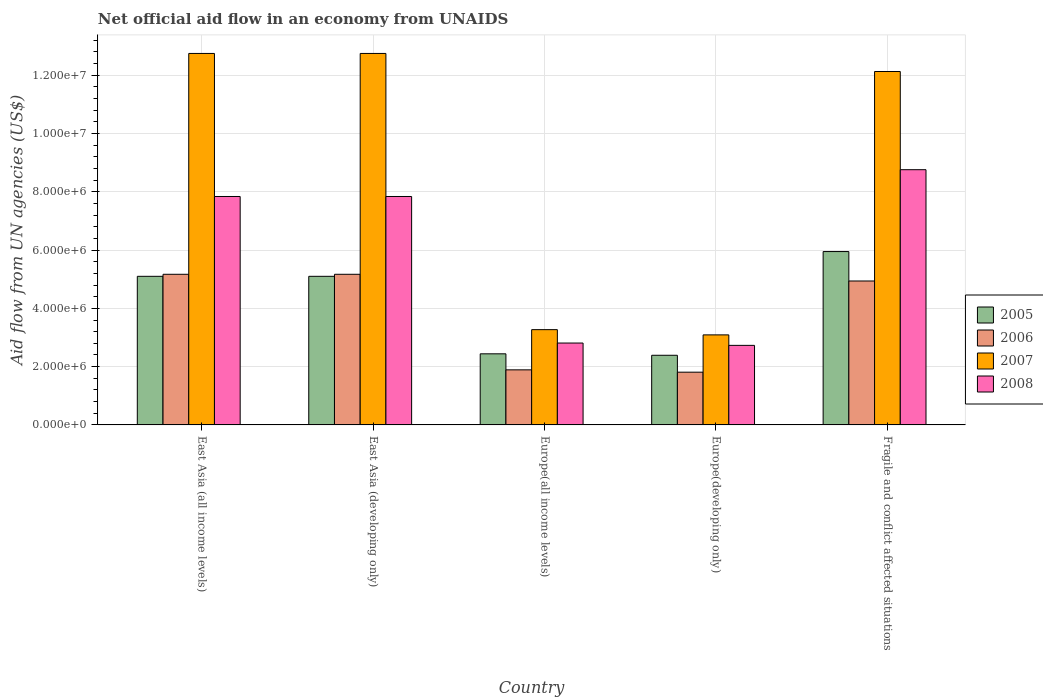How many different coloured bars are there?
Keep it short and to the point. 4. Are the number of bars per tick equal to the number of legend labels?
Give a very brief answer. Yes. How many bars are there on the 4th tick from the left?
Your answer should be compact. 4. How many bars are there on the 4th tick from the right?
Your response must be concise. 4. What is the label of the 3rd group of bars from the left?
Your response must be concise. Europe(all income levels). What is the net official aid flow in 2005 in Europe(all income levels)?
Provide a short and direct response. 2.44e+06. Across all countries, what is the maximum net official aid flow in 2008?
Give a very brief answer. 8.76e+06. Across all countries, what is the minimum net official aid flow in 2007?
Your answer should be very brief. 3.09e+06. In which country was the net official aid flow in 2008 maximum?
Your answer should be very brief. Fragile and conflict affected situations. In which country was the net official aid flow in 2008 minimum?
Your answer should be compact. Europe(developing only). What is the total net official aid flow in 2008 in the graph?
Offer a terse response. 3.00e+07. What is the difference between the net official aid flow in 2008 in East Asia (all income levels) and that in Europe(developing only)?
Offer a very short reply. 5.11e+06. What is the difference between the net official aid flow in 2006 in East Asia (all income levels) and the net official aid flow in 2007 in Fragile and conflict affected situations?
Your answer should be compact. -6.96e+06. What is the average net official aid flow in 2005 per country?
Your answer should be very brief. 4.20e+06. In how many countries, is the net official aid flow in 2007 greater than 12400000 US$?
Offer a terse response. 2. What is the ratio of the net official aid flow in 2008 in Europe(developing only) to that in Fragile and conflict affected situations?
Offer a very short reply. 0.31. Is the net official aid flow in 2008 in Europe(all income levels) less than that in Fragile and conflict affected situations?
Provide a short and direct response. Yes. Is the difference between the net official aid flow in 2007 in East Asia (developing only) and Europe(all income levels) greater than the difference between the net official aid flow in 2008 in East Asia (developing only) and Europe(all income levels)?
Make the answer very short. Yes. What is the difference between the highest and the second highest net official aid flow in 2005?
Keep it short and to the point. 8.50e+05. What is the difference between the highest and the lowest net official aid flow in 2005?
Your answer should be compact. 3.56e+06. In how many countries, is the net official aid flow in 2006 greater than the average net official aid flow in 2006 taken over all countries?
Ensure brevity in your answer.  3. What does the 4th bar from the right in Europe(all income levels) represents?
Your response must be concise. 2005. Is it the case that in every country, the sum of the net official aid flow in 2006 and net official aid flow in 2005 is greater than the net official aid flow in 2008?
Keep it short and to the point. Yes. Are all the bars in the graph horizontal?
Ensure brevity in your answer.  No. What is the difference between two consecutive major ticks on the Y-axis?
Your answer should be compact. 2.00e+06. Does the graph contain any zero values?
Give a very brief answer. No. Does the graph contain grids?
Your response must be concise. Yes. Where does the legend appear in the graph?
Ensure brevity in your answer.  Center right. How many legend labels are there?
Provide a succinct answer. 4. How are the legend labels stacked?
Offer a very short reply. Vertical. What is the title of the graph?
Your answer should be compact. Net official aid flow in an economy from UNAIDS. Does "2014" appear as one of the legend labels in the graph?
Your answer should be compact. No. What is the label or title of the Y-axis?
Make the answer very short. Aid flow from UN agencies (US$). What is the Aid flow from UN agencies (US$) of 2005 in East Asia (all income levels)?
Ensure brevity in your answer.  5.10e+06. What is the Aid flow from UN agencies (US$) of 2006 in East Asia (all income levels)?
Your response must be concise. 5.17e+06. What is the Aid flow from UN agencies (US$) of 2007 in East Asia (all income levels)?
Your answer should be very brief. 1.28e+07. What is the Aid flow from UN agencies (US$) of 2008 in East Asia (all income levels)?
Keep it short and to the point. 7.84e+06. What is the Aid flow from UN agencies (US$) in 2005 in East Asia (developing only)?
Offer a very short reply. 5.10e+06. What is the Aid flow from UN agencies (US$) of 2006 in East Asia (developing only)?
Offer a terse response. 5.17e+06. What is the Aid flow from UN agencies (US$) in 2007 in East Asia (developing only)?
Provide a succinct answer. 1.28e+07. What is the Aid flow from UN agencies (US$) of 2008 in East Asia (developing only)?
Your response must be concise. 7.84e+06. What is the Aid flow from UN agencies (US$) of 2005 in Europe(all income levels)?
Your response must be concise. 2.44e+06. What is the Aid flow from UN agencies (US$) in 2006 in Europe(all income levels)?
Your response must be concise. 1.89e+06. What is the Aid flow from UN agencies (US$) of 2007 in Europe(all income levels)?
Provide a succinct answer. 3.27e+06. What is the Aid flow from UN agencies (US$) in 2008 in Europe(all income levels)?
Your response must be concise. 2.81e+06. What is the Aid flow from UN agencies (US$) of 2005 in Europe(developing only)?
Give a very brief answer. 2.39e+06. What is the Aid flow from UN agencies (US$) in 2006 in Europe(developing only)?
Make the answer very short. 1.81e+06. What is the Aid flow from UN agencies (US$) in 2007 in Europe(developing only)?
Your response must be concise. 3.09e+06. What is the Aid flow from UN agencies (US$) of 2008 in Europe(developing only)?
Ensure brevity in your answer.  2.73e+06. What is the Aid flow from UN agencies (US$) of 2005 in Fragile and conflict affected situations?
Ensure brevity in your answer.  5.95e+06. What is the Aid flow from UN agencies (US$) in 2006 in Fragile and conflict affected situations?
Offer a very short reply. 4.94e+06. What is the Aid flow from UN agencies (US$) in 2007 in Fragile and conflict affected situations?
Offer a very short reply. 1.21e+07. What is the Aid flow from UN agencies (US$) of 2008 in Fragile and conflict affected situations?
Offer a terse response. 8.76e+06. Across all countries, what is the maximum Aid flow from UN agencies (US$) of 2005?
Ensure brevity in your answer.  5.95e+06. Across all countries, what is the maximum Aid flow from UN agencies (US$) of 2006?
Provide a short and direct response. 5.17e+06. Across all countries, what is the maximum Aid flow from UN agencies (US$) in 2007?
Offer a very short reply. 1.28e+07. Across all countries, what is the maximum Aid flow from UN agencies (US$) in 2008?
Your response must be concise. 8.76e+06. Across all countries, what is the minimum Aid flow from UN agencies (US$) of 2005?
Offer a terse response. 2.39e+06. Across all countries, what is the minimum Aid flow from UN agencies (US$) of 2006?
Give a very brief answer. 1.81e+06. Across all countries, what is the minimum Aid flow from UN agencies (US$) of 2007?
Give a very brief answer. 3.09e+06. Across all countries, what is the minimum Aid flow from UN agencies (US$) in 2008?
Give a very brief answer. 2.73e+06. What is the total Aid flow from UN agencies (US$) of 2005 in the graph?
Provide a succinct answer. 2.10e+07. What is the total Aid flow from UN agencies (US$) in 2006 in the graph?
Your answer should be very brief. 1.90e+07. What is the total Aid flow from UN agencies (US$) in 2007 in the graph?
Provide a short and direct response. 4.40e+07. What is the total Aid flow from UN agencies (US$) of 2008 in the graph?
Your answer should be very brief. 3.00e+07. What is the difference between the Aid flow from UN agencies (US$) of 2005 in East Asia (all income levels) and that in East Asia (developing only)?
Keep it short and to the point. 0. What is the difference between the Aid flow from UN agencies (US$) of 2006 in East Asia (all income levels) and that in East Asia (developing only)?
Provide a succinct answer. 0. What is the difference between the Aid flow from UN agencies (US$) of 2005 in East Asia (all income levels) and that in Europe(all income levels)?
Make the answer very short. 2.66e+06. What is the difference between the Aid flow from UN agencies (US$) of 2006 in East Asia (all income levels) and that in Europe(all income levels)?
Ensure brevity in your answer.  3.28e+06. What is the difference between the Aid flow from UN agencies (US$) of 2007 in East Asia (all income levels) and that in Europe(all income levels)?
Make the answer very short. 9.48e+06. What is the difference between the Aid flow from UN agencies (US$) of 2008 in East Asia (all income levels) and that in Europe(all income levels)?
Provide a short and direct response. 5.03e+06. What is the difference between the Aid flow from UN agencies (US$) in 2005 in East Asia (all income levels) and that in Europe(developing only)?
Your answer should be compact. 2.71e+06. What is the difference between the Aid flow from UN agencies (US$) in 2006 in East Asia (all income levels) and that in Europe(developing only)?
Your answer should be compact. 3.36e+06. What is the difference between the Aid flow from UN agencies (US$) of 2007 in East Asia (all income levels) and that in Europe(developing only)?
Provide a short and direct response. 9.66e+06. What is the difference between the Aid flow from UN agencies (US$) in 2008 in East Asia (all income levels) and that in Europe(developing only)?
Provide a succinct answer. 5.11e+06. What is the difference between the Aid flow from UN agencies (US$) of 2005 in East Asia (all income levels) and that in Fragile and conflict affected situations?
Ensure brevity in your answer.  -8.50e+05. What is the difference between the Aid flow from UN agencies (US$) in 2006 in East Asia (all income levels) and that in Fragile and conflict affected situations?
Your response must be concise. 2.30e+05. What is the difference between the Aid flow from UN agencies (US$) of 2007 in East Asia (all income levels) and that in Fragile and conflict affected situations?
Offer a very short reply. 6.20e+05. What is the difference between the Aid flow from UN agencies (US$) of 2008 in East Asia (all income levels) and that in Fragile and conflict affected situations?
Ensure brevity in your answer.  -9.20e+05. What is the difference between the Aid flow from UN agencies (US$) of 2005 in East Asia (developing only) and that in Europe(all income levels)?
Your answer should be compact. 2.66e+06. What is the difference between the Aid flow from UN agencies (US$) of 2006 in East Asia (developing only) and that in Europe(all income levels)?
Give a very brief answer. 3.28e+06. What is the difference between the Aid flow from UN agencies (US$) of 2007 in East Asia (developing only) and that in Europe(all income levels)?
Offer a terse response. 9.48e+06. What is the difference between the Aid flow from UN agencies (US$) in 2008 in East Asia (developing only) and that in Europe(all income levels)?
Your answer should be very brief. 5.03e+06. What is the difference between the Aid flow from UN agencies (US$) in 2005 in East Asia (developing only) and that in Europe(developing only)?
Keep it short and to the point. 2.71e+06. What is the difference between the Aid flow from UN agencies (US$) in 2006 in East Asia (developing only) and that in Europe(developing only)?
Make the answer very short. 3.36e+06. What is the difference between the Aid flow from UN agencies (US$) of 2007 in East Asia (developing only) and that in Europe(developing only)?
Offer a terse response. 9.66e+06. What is the difference between the Aid flow from UN agencies (US$) of 2008 in East Asia (developing only) and that in Europe(developing only)?
Your response must be concise. 5.11e+06. What is the difference between the Aid flow from UN agencies (US$) in 2005 in East Asia (developing only) and that in Fragile and conflict affected situations?
Your answer should be very brief. -8.50e+05. What is the difference between the Aid flow from UN agencies (US$) in 2007 in East Asia (developing only) and that in Fragile and conflict affected situations?
Your answer should be very brief. 6.20e+05. What is the difference between the Aid flow from UN agencies (US$) in 2008 in East Asia (developing only) and that in Fragile and conflict affected situations?
Provide a succinct answer. -9.20e+05. What is the difference between the Aid flow from UN agencies (US$) of 2008 in Europe(all income levels) and that in Europe(developing only)?
Your response must be concise. 8.00e+04. What is the difference between the Aid flow from UN agencies (US$) of 2005 in Europe(all income levels) and that in Fragile and conflict affected situations?
Ensure brevity in your answer.  -3.51e+06. What is the difference between the Aid flow from UN agencies (US$) of 2006 in Europe(all income levels) and that in Fragile and conflict affected situations?
Give a very brief answer. -3.05e+06. What is the difference between the Aid flow from UN agencies (US$) in 2007 in Europe(all income levels) and that in Fragile and conflict affected situations?
Ensure brevity in your answer.  -8.86e+06. What is the difference between the Aid flow from UN agencies (US$) in 2008 in Europe(all income levels) and that in Fragile and conflict affected situations?
Your response must be concise. -5.95e+06. What is the difference between the Aid flow from UN agencies (US$) of 2005 in Europe(developing only) and that in Fragile and conflict affected situations?
Make the answer very short. -3.56e+06. What is the difference between the Aid flow from UN agencies (US$) in 2006 in Europe(developing only) and that in Fragile and conflict affected situations?
Give a very brief answer. -3.13e+06. What is the difference between the Aid flow from UN agencies (US$) in 2007 in Europe(developing only) and that in Fragile and conflict affected situations?
Your response must be concise. -9.04e+06. What is the difference between the Aid flow from UN agencies (US$) of 2008 in Europe(developing only) and that in Fragile and conflict affected situations?
Your response must be concise. -6.03e+06. What is the difference between the Aid flow from UN agencies (US$) of 2005 in East Asia (all income levels) and the Aid flow from UN agencies (US$) of 2007 in East Asia (developing only)?
Offer a very short reply. -7.65e+06. What is the difference between the Aid flow from UN agencies (US$) of 2005 in East Asia (all income levels) and the Aid flow from UN agencies (US$) of 2008 in East Asia (developing only)?
Offer a terse response. -2.74e+06. What is the difference between the Aid flow from UN agencies (US$) of 2006 in East Asia (all income levels) and the Aid flow from UN agencies (US$) of 2007 in East Asia (developing only)?
Keep it short and to the point. -7.58e+06. What is the difference between the Aid flow from UN agencies (US$) in 2006 in East Asia (all income levels) and the Aid flow from UN agencies (US$) in 2008 in East Asia (developing only)?
Keep it short and to the point. -2.67e+06. What is the difference between the Aid flow from UN agencies (US$) of 2007 in East Asia (all income levels) and the Aid flow from UN agencies (US$) of 2008 in East Asia (developing only)?
Your answer should be very brief. 4.91e+06. What is the difference between the Aid flow from UN agencies (US$) of 2005 in East Asia (all income levels) and the Aid flow from UN agencies (US$) of 2006 in Europe(all income levels)?
Your answer should be very brief. 3.21e+06. What is the difference between the Aid flow from UN agencies (US$) of 2005 in East Asia (all income levels) and the Aid flow from UN agencies (US$) of 2007 in Europe(all income levels)?
Make the answer very short. 1.83e+06. What is the difference between the Aid flow from UN agencies (US$) in 2005 in East Asia (all income levels) and the Aid flow from UN agencies (US$) in 2008 in Europe(all income levels)?
Make the answer very short. 2.29e+06. What is the difference between the Aid flow from UN agencies (US$) in 2006 in East Asia (all income levels) and the Aid flow from UN agencies (US$) in 2007 in Europe(all income levels)?
Make the answer very short. 1.90e+06. What is the difference between the Aid flow from UN agencies (US$) in 2006 in East Asia (all income levels) and the Aid flow from UN agencies (US$) in 2008 in Europe(all income levels)?
Your response must be concise. 2.36e+06. What is the difference between the Aid flow from UN agencies (US$) in 2007 in East Asia (all income levels) and the Aid flow from UN agencies (US$) in 2008 in Europe(all income levels)?
Ensure brevity in your answer.  9.94e+06. What is the difference between the Aid flow from UN agencies (US$) in 2005 in East Asia (all income levels) and the Aid flow from UN agencies (US$) in 2006 in Europe(developing only)?
Ensure brevity in your answer.  3.29e+06. What is the difference between the Aid flow from UN agencies (US$) of 2005 in East Asia (all income levels) and the Aid flow from UN agencies (US$) of 2007 in Europe(developing only)?
Provide a short and direct response. 2.01e+06. What is the difference between the Aid flow from UN agencies (US$) in 2005 in East Asia (all income levels) and the Aid flow from UN agencies (US$) in 2008 in Europe(developing only)?
Provide a short and direct response. 2.37e+06. What is the difference between the Aid flow from UN agencies (US$) in 2006 in East Asia (all income levels) and the Aid flow from UN agencies (US$) in 2007 in Europe(developing only)?
Give a very brief answer. 2.08e+06. What is the difference between the Aid flow from UN agencies (US$) of 2006 in East Asia (all income levels) and the Aid flow from UN agencies (US$) of 2008 in Europe(developing only)?
Offer a very short reply. 2.44e+06. What is the difference between the Aid flow from UN agencies (US$) in 2007 in East Asia (all income levels) and the Aid flow from UN agencies (US$) in 2008 in Europe(developing only)?
Provide a short and direct response. 1.00e+07. What is the difference between the Aid flow from UN agencies (US$) of 2005 in East Asia (all income levels) and the Aid flow from UN agencies (US$) of 2006 in Fragile and conflict affected situations?
Your response must be concise. 1.60e+05. What is the difference between the Aid flow from UN agencies (US$) of 2005 in East Asia (all income levels) and the Aid flow from UN agencies (US$) of 2007 in Fragile and conflict affected situations?
Make the answer very short. -7.03e+06. What is the difference between the Aid flow from UN agencies (US$) of 2005 in East Asia (all income levels) and the Aid flow from UN agencies (US$) of 2008 in Fragile and conflict affected situations?
Your response must be concise. -3.66e+06. What is the difference between the Aid flow from UN agencies (US$) in 2006 in East Asia (all income levels) and the Aid flow from UN agencies (US$) in 2007 in Fragile and conflict affected situations?
Provide a short and direct response. -6.96e+06. What is the difference between the Aid flow from UN agencies (US$) in 2006 in East Asia (all income levels) and the Aid flow from UN agencies (US$) in 2008 in Fragile and conflict affected situations?
Give a very brief answer. -3.59e+06. What is the difference between the Aid flow from UN agencies (US$) in 2007 in East Asia (all income levels) and the Aid flow from UN agencies (US$) in 2008 in Fragile and conflict affected situations?
Give a very brief answer. 3.99e+06. What is the difference between the Aid flow from UN agencies (US$) of 2005 in East Asia (developing only) and the Aid flow from UN agencies (US$) of 2006 in Europe(all income levels)?
Provide a succinct answer. 3.21e+06. What is the difference between the Aid flow from UN agencies (US$) in 2005 in East Asia (developing only) and the Aid flow from UN agencies (US$) in 2007 in Europe(all income levels)?
Your answer should be very brief. 1.83e+06. What is the difference between the Aid flow from UN agencies (US$) in 2005 in East Asia (developing only) and the Aid flow from UN agencies (US$) in 2008 in Europe(all income levels)?
Your answer should be compact. 2.29e+06. What is the difference between the Aid flow from UN agencies (US$) of 2006 in East Asia (developing only) and the Aid flow from UN agencies (US$) of 2007 in Europe(all income levels)?
Your answer should be compact. 1.90e+06. What is the difference between the Aid flow from UN agencies (US$) in 2006 in East Asia (developing only) and the Aid flow from UN agencies (US$) in 2008 in Europe(all income levels)?
Your answer should be very brief. 2.36e+06. What is the difference between the Aid flow from UN agencies (US$) in 2007 in East Asia (developing only) and the Aid flow from UN agencies (US$) in 2008 in Europe(all income levels)?
Keep it short and to the point. 9.94e+06. What is the difference between the Aid flow from UN agencies (US$) in 2005 in East Asia (developing only) and the Aid flow from UN agencies (US$) in 2006 in Europe(developing only)?
Give a very brief answer. 3.29e+06. What is the difference between the Aid flow from UN agencies (US$) in 2005 in East Asia (developing only) and the Aid flow from UN agencies (US$) in 2007 in Europe(developing only)?
Your response must be concise. 2.01e+06. What is the difference between the Aid flow from UN agencies (US$) in 2005 in East Asia (developing only) and the Aid flow from UN agencies (US$) in 2008 in Europe(developing only)?
Your answer should be compact. 2.37e+06. What is the difference between the Aid flow from UN agencies (US$) of 2006 in East Asia (developing only) and the Aid flow from UN agencies (US$) of 2007 in Europe(developing only)?
Provide a succinct answer. 2.08e+06. What is the difference between the Aid flow from UN agencies (US$) of 2006 in East Asia (developing only) and the Aid flow from UN agencies (US$) of 2008 in Europe(developing only)?
Your answer should be very brief. 2.44e+06. What is the difference between the Aid flow from UN agencies (US$) in 2007 in East Asia (developing only) and the Aid flow from UN agencies (US$) in 2008 in Europe(developing only)?
Ensure brevity in your answer.  1.00e+07. What is the difference between the Aid flow from UN agencies (US$) in 2005 in East Asia (developing only) and the Aid flow from UN agencies (US$) in 2007 in Fragile and conflict affected situations?
Provide a short and direct response. -7.03e+06. What is the difference between the Aid flow from UN agencies (US$) of 2005 in East Asia (developing only) and the Aid flow from UN agencies (US$) of 2008 in Fragile and conflict affected situations?
Make the answer very short. -3.66e+06. What is the difference between the Aid flow from UN agencies (US$) in 2006 in East Asia (developing only) and the Aid flow from UN agencies (US$) in 2007 in Fragile and conflict affected situations?
Your response must be concise. -6.96e+06. What is the difference between the Aid flow from UN agencies (US$) in 2006 in East Asia (developing only) and the Aid flow from UN agencies (US$) in 2008 in Fragile and conflict affected situations?
Make the answer very short. -3.59e+06. What is the difference between the Aid flow from UN agencies (US$) in 2007 in East Asia (developing only) and the Aid flow from UN agencies (US$) in 2008 in Fragile and conflict affected situations?
Your answer should be very brief. 3.99e+06. What is the difference between the Aid flow from UN agencies (US$) in 2005 in Europe(all income levels) and the Aid flow from UN agencies (US$) in 2006 in Europe(developing only)?
Your response must be concise. 6.30e+05. What is the difference between the Aid flow from UN agencies (US$) in 2005 in Europe(all income levels) and the Aid flow from UN agencies (US$) in 2007 in Europe(developing only)?
Make the answer very short. -6.50e+05. What is the difference between the Aid flow from UN agencies (US$) in 2006 in Europe(all income levels) and the Aid flow from UN agencies (US$) in 2007 in Europe(developing only)?
Provide a succinct answer. -1.20e+06. What is the difference between the Aid flow from UN agencies (US$) in 2006 in Europe(all income levels) and the Aid flow from UN agencies (US$) in 2008 in Europe(developing only)?
Offer a terse response. -8.40e+05. What is the difference between the Aid flow from UN agencies (US$) in 2007 in Europe(all income levels) and the Aid flow from UN agencies (US$) in 2008 in Europe(developing only)?
Ensure brevity in your answer.  5.40e+05. What is the difference between the Aid flow from UN agencies (US$) of 2005 in Europe(all income levels) and the Aid flow from UN agencies (US$) of 2006 in Fragile and conflict affected situations?
Give a very brief answer. -2.50e+06. What is the difference between the Aid flow from UN agencies (US$) of 2005 in Europe(all income levels) and the Aid flow from UN agencies (US$) of 2007 in Fragile and conflict affected situations?
Provide a succinct answer. -9.69e+06. What is the difference between the Aid flow from UN agencies (US$) of 2005 in Europe(all income levels) and the Aid flow from UN agencies (US$) of 2008 in Fragile and conflict affected situations?
Your response must be concise. -6.32e+06. What is the difference between the Aid flow from UN agencies (US$) in 2006 in Europe(all income levels) and the Aid flow from UN agencies (US$) in 2007 in Fragile and conflict affected situations?
Make the answer very short. -1.02e+07. What is the difference between the Aid flow from UN agencies (US$) in 2006 in Europe(all income levels) and the Aid flow from UN agencies (US$) in 2008 in Fragile and conflict affected situations?
Ensure brevity in your answer.  -6.87e+06. What is the difference between the Aid flow from UN agencies (US$) in 2007 in Europe(all income levels) and the Aid flow from UN agencies (US$) in 2008 in Fragile and conflict affected situations?
Ensure brevity in your answer.  -5.49e+06. What is the difference between the Aid flow from UN agencies (US$) of 2005 in Europe(developing only) and the Aid flow from UN agencies (US$) of 2006 in Fragile and conflict affected situations?
Offer a very short reply. -2.55e+06. What is the difference between the Aid flow from UN agencies (US$) of 2005 in Europe(developing only) and the Aid flow from UN agencies (US$) of 2007 in Fragile and conflict affected situations?
Your response must be concise. -9.74e+06. What is the difference between the Aid flow from UN agencies (US$) of 2005 in Europe(developing only) and the Aid flow from UN agencies (US$) of 2008 in Fragile and conflict affected situations?
Provide a short and direct response. -6.37e+06. What is the difference between the Aid flow from UN agencies (US$) of 2006 in Europe(developing only) and the Aid flow from UN agencies (US$) of 2007 in Fragile and conflict affected situations?
Your answer should be very brief. -1.03e+07. What is the difference between the Aid flow from UN agencies (US$) in 2006 in Europe(developing only) and the Aid flow from UN agencies (US$) in 2008 in Fragile and conflict affected situations?
Give a very brief answer. -6.95e+06. What is the difference between the Aid flow from UN agencies (US$) in 2007 in Europe(developing only) and the Aid flow from UN agencies (US$) in 2008 in Fragile and conflict affected situations?
Ensure brevity in your answer.  -5.67e+06. What is the average Aid flow from UN agencies (US$) of 2005 per country?
Your answer should be compact. 4.20e+06. What is the average Aid flow from UN agencies (US$) in 2006 per country?
Your answer should be very brief. 3.80e+06. What is the average Aid flow from UN agencies (US$) of 2007 per country?
Provide a succinct answer. 8.80e+06. What is the average Aid flow from UN agencies (US$) of 2008 per country?
Offer a terse response. 6.00e+06. What is the difference between the Aid flow from UN agencies (US$) in 2005 and Aid flow from UN agencies (US$) in 2007 in East Asia (all income levels)?
Offer a very short reply. -7.65e+06. What is the difference between the Aid flow from UN agencies (US$) of 2005 and Aid flow from UN agencies (US$) of 2008 in East Asia (all income levels)?
Keep it short and to the point. -2.74e+06. What is the difference between the Aid flow from UN agencies (US$) in 2006 and Aid flow from UN agencies (US$) in 2007 in East Asia (all income levels)?
Your response must be concise. -7.58e+06. What is the difference between the Aid flow from UN agencies (US$) of 2006 and Aid flow from UN agencies (US$) of 2008 in East Asia (all income levels)?
Provide a short and direct response. -2.67e+06. What is the difference between the Aid flow from UN agencies (US$) in 2007 and Aid flow from UN agencies (US$) in 2008 in East Asia (all income levels)?
Give a very brief answer. 4.91e+06. What is the difference between the Aid flow from UN agencies (US$) in 2005 and Aid flow from UN agencies (US$) in 2006 in East Asia (developing only)?
Your answer should be compact. -7.00e+04. What is the difference between the Aid flow from UN agencies (US$) of 2005 and Aid flow from UN agencies (US$) of 2007 in East Asia (developing only)?
Make the answer very short. -7.65e+06. What is the difference between the Aid flow from UN agencies (US$) in 2005 and Aid flow from UN agencies (US$) in 2008 in East Asia (developing only)?
Your answer should be compact. -2.74e+06. What is the difference between the Aid flow from UN agencies (US$) in 2006 and Aid flow from UN agencies (US$) in 2007 in East Asia (developing only)?
Make the answer very short. -7.58e+06. What is the difference between the Aid flow from UN agencies (US$) in 2006 and Aid flow from UN agencies (US$) in 2008 in East Asia (developing only)?
Give a very brief answer. -2.67e+06. What is the difference between the Aid flow from UN agencies (US$) of 2007 and Aid flow from UN agencies (US$) of 2008 in East Asia (developing only)?
Provide a short and direct response. 4.91e+06. What is the difference between the Aid flow from UN agencies (US$) in 2005 and Aid flow from UN agencies (US$) in 2007 in Europe(all income levels)?
Your answer should be compact. -8.30e+05. What is the difference between the Aid flow from UN agencies (US$) in 2005 and Aid flow from UN agencies (US$) in 2008 in Europe(all income levels)?
Ensure brevity in your answer.  -3.70e+05. What is the difference between the Aid flow from UN agencies (US$) of 2006 and Aid flow from UN agencies (US$) of 2007 in Europe(all income levels)?
Provide a succinct answer. -1.38e+06. What is the difference between the Aid flow from UN agencies (US$) in 2006 and Aid flow from UN agencies (US$) in 2008 in Europe(all income levels)?
Offer a very short reply. -9.20e+05. What is the difference between the Aid flow from UN agencies (US$) in 2007 and Aid flow from UN agencies (US$) in 2008 in Europe(all income levels)?
Give a very brief answer. 4.60e+05. What is the difference between the Aid flow from UN agencies (US$) in 2005 and Aid flow from UN agencies (US$) in 2006 in Europe(developing only)?
Make the answer very short. 5.80e+05. What is the difference between the Aid flow from UN agencies (US$) in 2005 and Aid flow from UN agencies (US$) in 2007 in Europe(developing only)?
Give a very brief answer. -7.00e+05. What is the difference between the Aid flow from UN agencies (US$) of 2006 and Aid flow from UN agencies (US$) of 2007 in Europe(developing only)?
Offer a very short reply. -1.28e+06. What is the difference between the Aid flow from UN agencies (US$) in 2006 and Aid flow from UN agencies (US$) in 2008 in Europe(developing only)?
Make the answer very short. -9.20e+05. What is the difference between the Aid flow from UN agencies (US$) of 2007 and Aid flow from UN agencies (US$) of 2008 in Europe(developing only)?
Offer a very short reply. 3.60e+05. What is the difference between the Aid flow from UN agencies (US$) of 2005 and Aid flow from UN agencies (US$) of 2006 in Fragile and conflict affected situations?
Offer a very short reply. 1.01e+06. What is the difference between the Aid flow from UN agencies (US$) in 2005 and Aid flow from UN agencies (US$) in 2007 in Fragile and conflict affected situations?
Keep it short and to the point. -6.18e+06. What is the difference between the Aid flow from UN agencies (US$) in 2005 and Aid flow from UN agencies (US$) in 2008 in Fragile and conflict affected situations?
Make the answer very short. -2.81e+06. What is the difference between the Aid flow from UN agencies (US$) in 2006 and Aid flow from UN agencies (US$) in 2007 in Fragile and conflict affected situations?
Offer a very short reply. -7.19e+06. What is the difference between the Aid flow from UN agencies (US$) in 2006 and Aid flow from UN agencies (US$) in 2008 in Fragile and conflict affected situations?
Provide a short and direct response. -3.82e+06. What is the difference between the Aid flow from UN agencies (US$) in 2007 and Aid flow from UN agencies (US$) in 2008 in Fragile and conflict affected situations?
Offer a very short reply. 3.37e+06. What is the ratio of the Aid flow from UN agencies (US$) in 2006 in East Asia (all income levels) to that in East Asia (developing only)?
Your answer should be compact. 1. What is the ratio of the Aid flow from UN agencies (US$) in 2007 in East Asia (all income levels) to that in East Asia (developing only)?
Keep it short and to the point. 1. What is the ratio of the Aid flow from UN agencies (US$) in 2008 in East Asia (all income levels) to that in East Asia (developing only)?
Provide a succinct answer. 1. What is the ratio of the Aid flow from UN agencies (US$) in 2005 in East Asia (all income levels) to that in Europe(all income levels)?
Keep it short and to the point. 2.09. What is the ratio of the Aid flow from UN agencies (US$) of 2006 in East Asia (all income levels) to that in Europe(all income levels)?
Your answer should be very brief. 2.74. What is the ratio of the Aid flow from UN agencies (US$) in 2007 in East Asia (all income levels) to that in Europe(all income levels)?
Your response must be concise. 3.9. What is the ratio of the Aid flow from UN agencies (US$) in 2008 in East Asia (all income levels) to that in Europe(all income levels)?
Provide a short and direct response. 2.79. What is the ratio of the Aid flow from UN agencies (US$) of 2005 in East Asia (all income levels) to that in Europe(developing only)?
Give a very brief answer. 2.13. What is the ratio of the Aid flow from UN agencies (US$) of 2006 in East Asia (all income levels) to that in Europe(developing only)?
Offer a very short reply. 2.86. What is the ratio of the Aid flow from UN agencies (US$) in 2007 in East Asia (all income levels) to that in Europe(developing only)?
Your answer should be compact. 4.13. What is the ratio of the Aid flow from UN agencies (US$) of 2008 in East Asia (all income levels) to that in Europe(developing only)?
Your answer should be compact. 2.87. What is the ratio of the Aid flow from UN agencies (US$) of 2005 in East Asia (all income levels) to that in Fragile and conflict affected situations?
Ensure brevity in your answer.  0.86. What is the ratio of the Aid flow from UN agencies (US$) in 2006 in East Asia (all income levels) to that in Fragile and conflict affected situations?
Your answer should be very brief. 1.05. What is the ratio of the Aid flow from UN agencies (US$) of 2007 in East Asia (all income levels) to that in Fragile and conflict affected situations?
Offer a very short reply. 1.05. What is the ratio of the Aid flow from UN agencies (US$) of 2008 in East Asia (all income levels) to that in Fragile and conflict affected situations?
Your response must be concise. 0.9. What is the ratio of the Aid flow from UN agencies (US$) of 2005 in East Asia (developing only) to that in Europe(all income levels)?
Provide a short and direct response. 2.09. What is the ratio of the Aid flow from UN agencies (US$) in 2006 in East Asia (developing only) to that in Europe(all income levels)?
Keep it short and to the point. 2.74. What is the ratio of the Aid flow from UN agencies (US$) in 2007 in East Asia (developing only) to that in Europe(all income levels)?
Give a very brief answer. 3.9. What is the ratio of the Aid flow from UN agencies (US$) in 2008 in East Asia (developing only) to that in Europe(all income levels)?
Keep it short and to the point. 2.79. What is the ratio of the Aid flow from UN agencies (US$) of 2005 in East Asia (developing only) to that in Europe(developing only)?
Make the answer very short. 2.13. What is the ratio of the Aid flow from UN agencies (US$) in 2006 in East Asia (developing only) to that in Europe(developing only)?
Your answer should be very brief. 2.86. What is the ratio of the Aid flow from UN agencies (US$) in 2007 in East Asia (developing only) to that in Europe(developing only)?
Provide a short and direct response. 4.13. What is the ratio of the Aid flow from UN agencies (US$) in 2008 in East Asia (developing only) to that in Europe(developing only)?
Your answer should be very brief. 2.87. What is the ratio of the Aid flow from UN agencies (US$) of 2006 in East Asia (developing only) to that in Fragile and conflict affected situations?
Give a very brief answer. 1.05. What is the ratio of the Aid flow from UN agencies (US$) in 2007 in East Asia (developing only) to that in Fragile and conflict affected situations?
Keep it short and to the point. 1.05. What is the ratio of the Aid flow from UN agencies (US$) of 2008 in East Asia (developing only) to that in Fragile and conflict affected situations?
Offer a terse response. 0.9. What is the ratio of the Aid flow from UN agencies (US$) of 2005 in Europe(all income levels) to that in Europe(developing only)?
Offer a very short reply. 1.02. What is the ratio of the Aid flow from UN agencies (US$) of 2006 in Europe(all income levels) to that in Europe(developing only)?
Offer a very short reply. 1.04. What is the ratio of the Aid flow from UN agencies (US$) in 2007 in Europe(all income levels) to that in Europe(developing only)?
Your answer should be very brief. 1.06. What is the ratio of the Aid flow from UN agencies (US$) of 2008 in Europe(all income levels) to that in Europe(developing only)?
Keep it short and to the point. 1.03. What is the ratio of the Aid flow from UN agencies (US$) in 2005 in Europe(all income levels) to that in Fragile and conflict affected situations?
Offer a terse response. 0.41. What is the ratio of the Aid flow from UN agencies (US$) of 2006 in Europe(all income levels) to that in Fragile and conflict affected situations?
Your answer should be very brief. 0.38. What is the ratio of the Aid flow from UN agencies (US$) of 2007 in Europe(all income levels) to that in Fragile and conflict affected situations?
Make the answer very short. 0.27. What is the ratio of the Aid flow from UN agencies (US$) in 2008 in Europe(all income levels) to that in Fragile and conflict affected situations?
Provide a short and direct response. 0.32. What is the ratio of the Aid flow from UN agencies (US$) of 2005 in Europe(developing only) to that in Fragile and conflict affected situations?
Provide a succinct answer. 0.4. What is the ratio of the Aid flow from UN agencies (US$) in 2006 in Europe(developing only) to that in Fragile and conflict affected situations?
Provide a succinct answer. 0.37. What is the ratio of the Aid flow from UN agencies (US$) in 2007 in Europe(developing only) to that in Fragile and conflict affected situations?
Make the answer very short. 0.25. What is the ratio of the Aid flow from UN agencies (US$) in 2008 in Europe(developing only) to that in Fragile and conflict affected situations?
Give a very brief answer. 0.31. What is the difference between the highest and the second highest Aid flow from UN agencies (US$) of 2005?
Your response must be concise. 8.50e+05. What is the difference between the highest and the second highest Aid flow from UN agencies (US$) in 2008?
Give a very brief answer. 9.20e+05. What is the difference between the highest and the lowest Aid flow from UN agencies (US$) in 2005?
Keep it short and to the point. 3.56e+06. What is the difference between the highest and the lowest Aid flow from UN agencies (US$) of 2006?
Your answer should be compact. 3.36e+06. What is the difference between the highest and the lowest Aid flow from UN agencies (US$) of 2007?
Your answer should be compact. 9.66e+06. What is the difference between the highest and the lowest Aid flow from UN agencies (US$) of 2008?
Ensure brevity in your answer.  6.03e+06. 